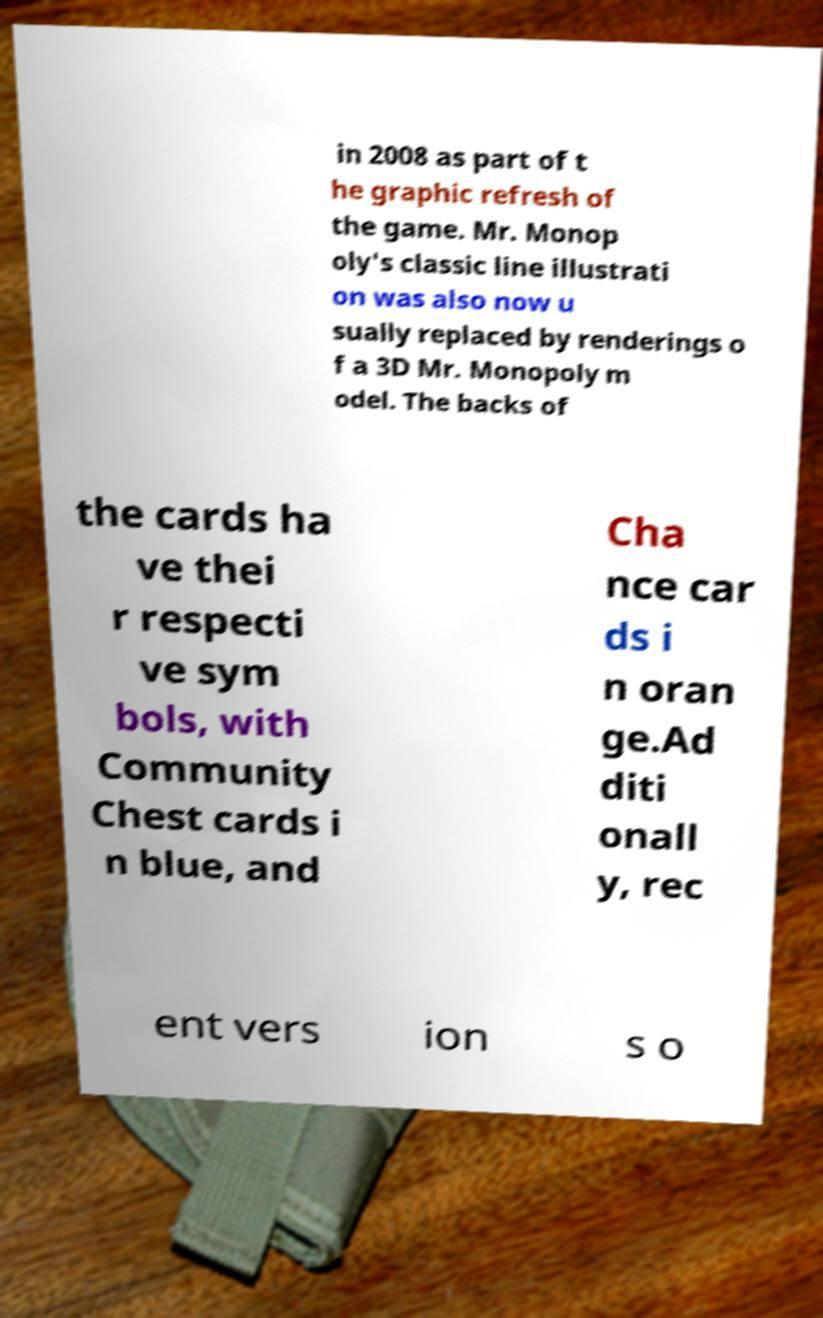For documentation purposes, I need the text within this image transcribed. Could you provide that? in 2008 as part of t he graphic refresh of the game. Mr. Monop oly's classic line illustrati on was also now u sually replaced by renderings o f a 3D Mr. Monopoly m odel. The backs of the cards ha ve thei r respecti ve sym bols, with Community Chest cards i n blue, and Cha nce car ds i n oran ge.Ad diti onall y, rec ent vers ion s o 